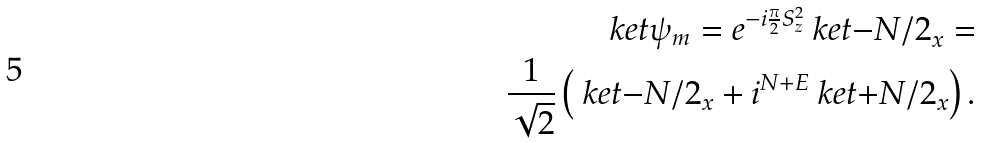Convert formula to latex. <formula><loc_0><loc_0><loc_500><loc_500>\ k e t { \psi _ { m } } = e ^ { - i \frac { \pi } { 2 } S _ { z } ^ { 2 } } \ k e t { - N / 2 } _ { x } = \\ \frac { 1 } { \sqrt { 2 } } \left ( \ k e t { - N / 2 } _ { x } + i ^ { N + E } \ k e t { + N / 2 } _ { x } \right ) .</formula> 